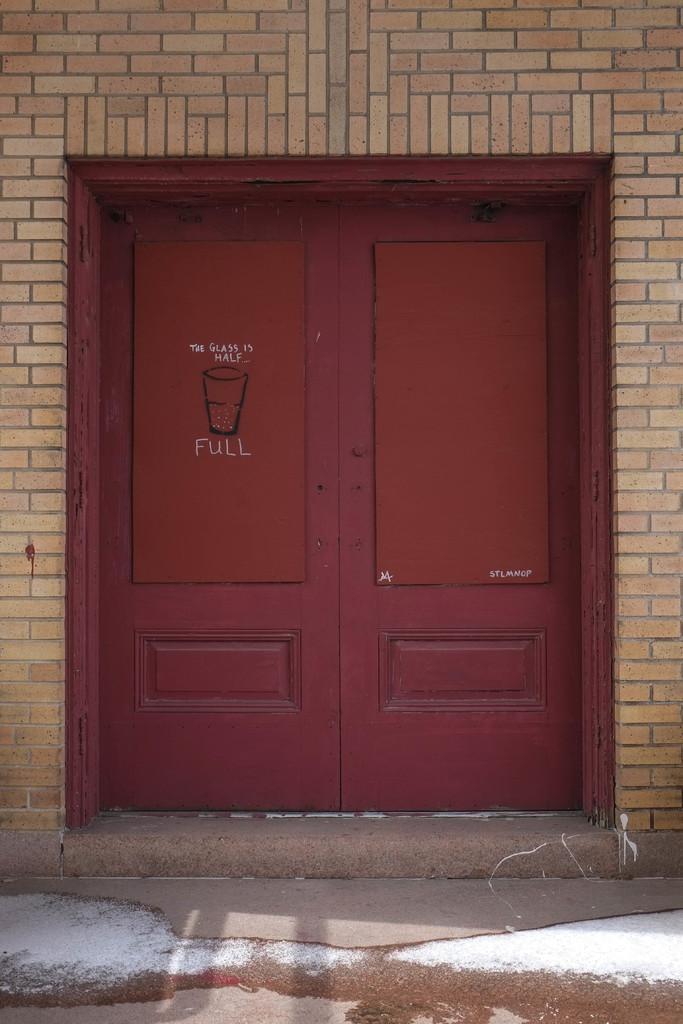Could you give a brief overview of what you see in this image? In the picture we can see door which is in red color and there is brick wall. 